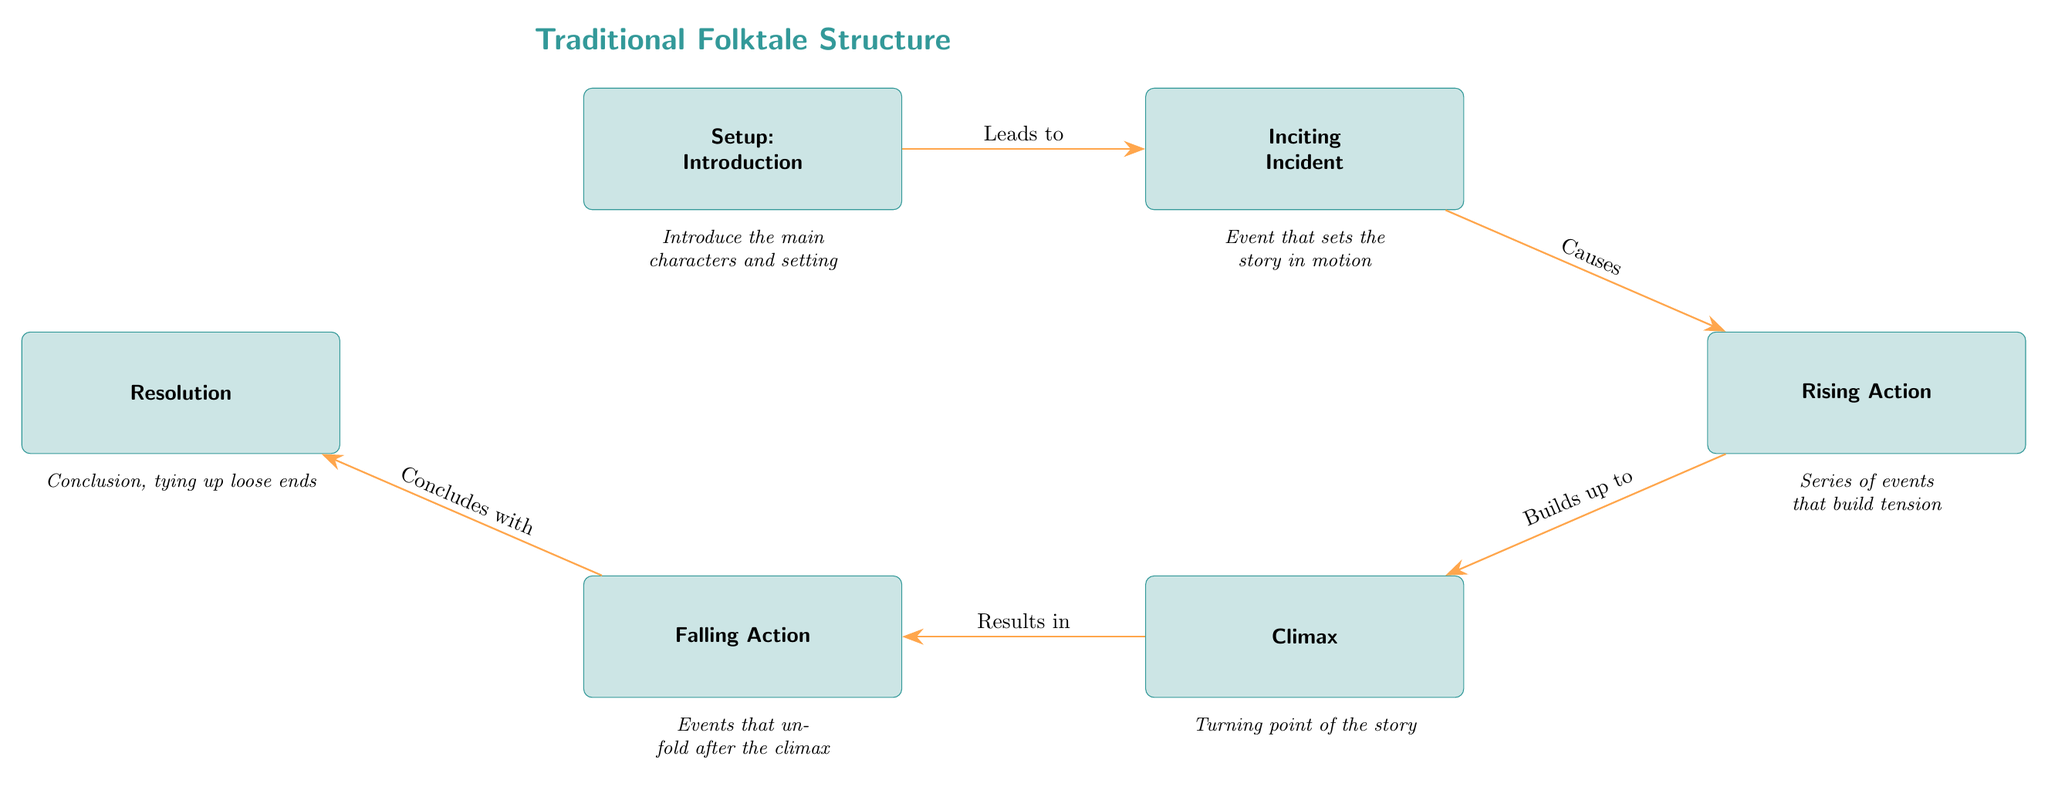What is the title of the diagram? The title is found at the top of the diagram, presenting the overall theme or subject matter. In this case, it specifically states "Traditional Folktale Structure".
Answer: Traditional Folktale Structure How many nodes are presented in the diagram? By counting each distinct box or rectangle representing a component of the structure, we find that there are six nodes included in the diagram.
Answer: 6 What does the "Climax" node represent? The "Climax" node is defined within the diagram as the "Turning point of the story", which indicates it is a critical moment in the folktale structure.
Answer: Turning point of the story Which node follows the "Rising Action"? The flow of the diagram is strictly linear from the "Rising Action" node. Following this, the next node is the "Climax", indicating the story's peak.
Answer: Climax What description is given for the "Resolution" node? The "Resolution" node is accompanied by a description stating "Conclusion, tying up loose ends", which clarifies its purpose within the narrative structure.
Answer: Conclusion, tying up loose ends What type of relationship is indicated between the "Inciting Incident" and "Rising Action"? The diagram specifies a causal relationship using the phrase "Causes", which denotes that the "Inciting Incident" directly leads to the "Rising Action".
Answer: Causes What is the function of the "Falling Action" in relation to the "Climax"? In the diagram, the "Falling Action" is shown to occur as a result of the "Climax", indicating it's an outcome or continuation after the peak of the story.
Answer: Results in Which node introduces the characters and setting? The very first node in the diagram, labeled "Setup", includes the introductory elements, specifically mentioning the introduction of the characters and setting.
Answer: Setup 